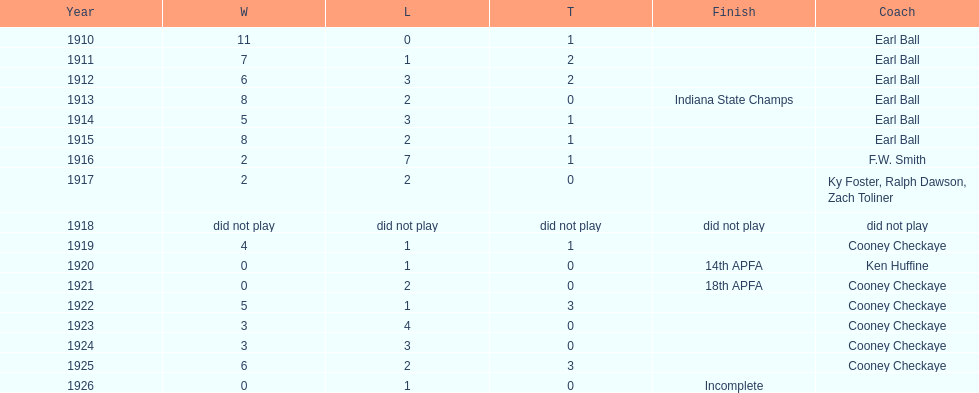Over how many years was cooney checkaye the coach of the muncie flyers? 6. 